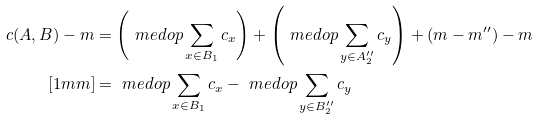<formula> <loc_0><loc_0><loc_500><loc_500>c ( A , B ) - m & = \left ( \ m e d o p \sum _ { x \in B _ { 1 } } c _ { x } \right ) + \left ( \ m e d o p \sum _ { y \in A ^ { \prime \prime } _ { 2 } } c _ { y } \right ) + ( m - m ^ { \prime \prime } ) - m \\ [ 1 m m ] & = \ m e d o p \sum _ { x \in B _ { 1 } } c _ { x } - \ m e d o p \sum _ { y \in B ^ { \prime \prime } _ { 2 } } c _ { y }</formula> 